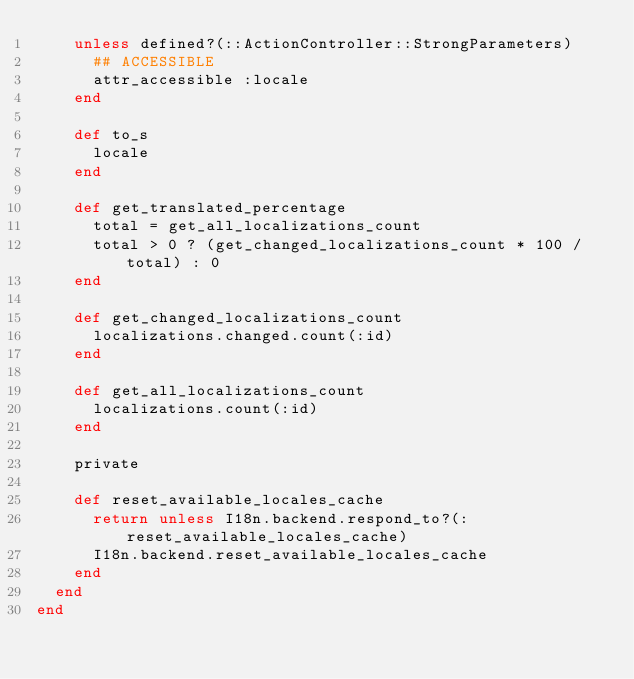<code> <loc_0><loc_0><loc_500><loc_500><_Ruby_>    unless defined?(::ActionController::StrongParameters)
      ## ACCESSIBLE
      attr_accessible :locale
    end

    def to_s
      locale
    end

    def get_translated_percentage
      total = get_all_localizations_count
      total > 0 ? (get_changed_localizations_count * 100 / total) : 0
    end

    def get_changed_localizations_count
      localizations.changed.count(:id)
    end

    def get_all_localizations_count
      localizations.count(:id)
    end

    private

    def reset_available_locales_cache
      return unless I18n.backend.respond_to?(:reset_available_locales_cache)
      I18n.backend.reset_available_locales_cache
    end
  end
end
</code> 